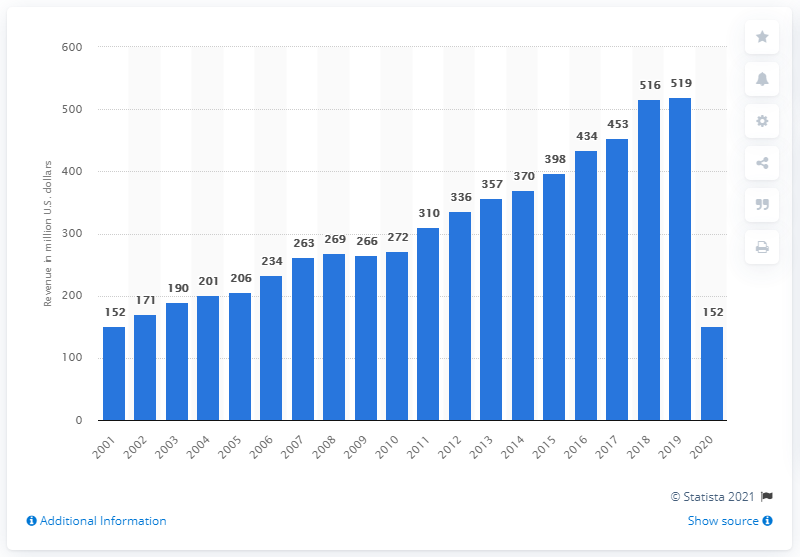Identify some key points in this picture. The Boston Red Sox generated a revenue of 152 million dollars in 2020. 